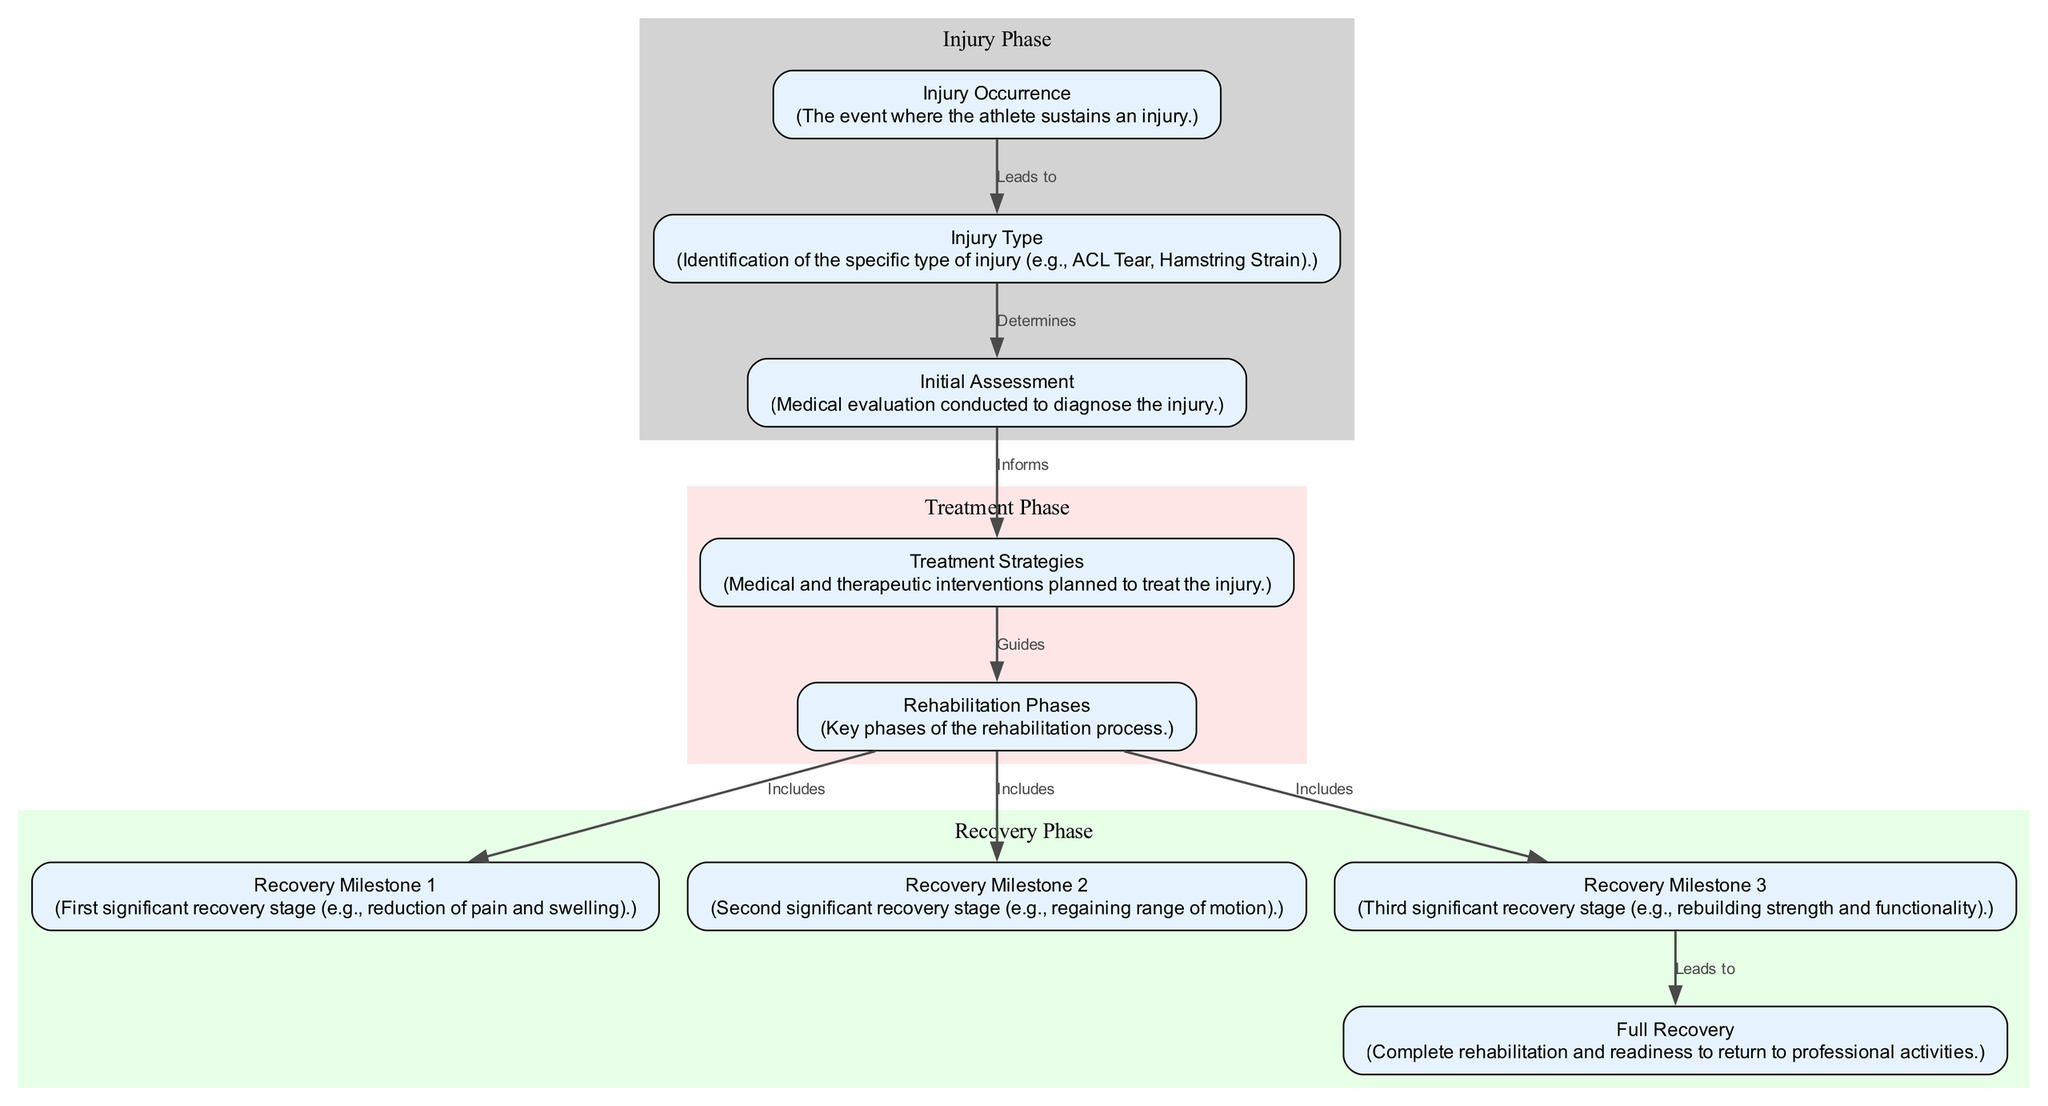What is the first node in the diagram? The diagram starts with the node labeled "Injury Occurrence," which marks the beginning of the injury process flow.
Answer: Injury Occurrence How many recovery milestones are there? The diagram lists three distinct recovery milestones, correlating with specific stages in the recovery process.
Answer: 3 What does "Initial Assessment" inform? The "Initial Assessment" node directly informs "Treatment Strategies," indicating that the assessment results guide the treatment plan.
Answer: Treatment Strategies Which node describes the reduction of pain and swelling? The node labeled "Recovery Milestone 1" represents the first significant recovery stage, which specifically focuses on the reduction of pain and swelling.
Answer: Recovery Milestone 1 What phase includes "Rebuilding strength and functionality"? "Rehabilitation Phases" includes "Recovery Milestone 3," which specifically describes the rebuilding of strength and functionality as part of the recovery process.
Answer: Recovery Milestone 3 Which phase follows the treatment strategies in the timeline? After "Treatment Strategies," the timeline leads to the "Rehabilitation Phases," indicating the next important step following treatment.
Answer: Rehabilitation Phases What injury type directly affects the initial assessment? The "Injury Type" node determines the "Initial Assessment," signifying that the identified injury type is critical to conducting the right assessment.
Answer: Injury Type Which milestone leads to "Full Recovery"? "Recovery Milestone 3" leads to "Full Recovery," indicating that achieving this milestone is essential for completing the rehabilitation process and returning to activity.
Answer: Recovery Milestone 3 What does the cluster representing "Recovery Phase" contain? The "Recovery Phase" cluster contains the nodes for "Recovery Milestone 1," "Recovery Milestone 2," "Recovery Milestone 3," and "Full Recovery," outlining the stages of recovery.
Answer: Recovery Milestone 1, Recovery Milestone 2, Recovery Milestone 3, Full Recovery 